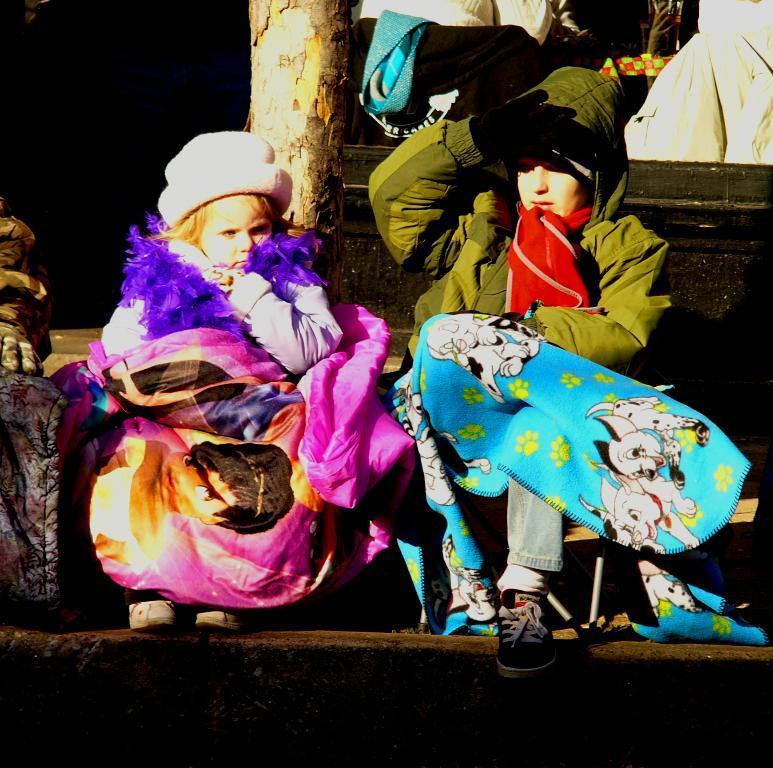In one or two sentences, can you explain what this image depicts? Here I can see two girls wearing jackets, caps on their heads, gloves to the hands and sitting on the stairs by holding bags. In the background, I can see a tree trunk. 